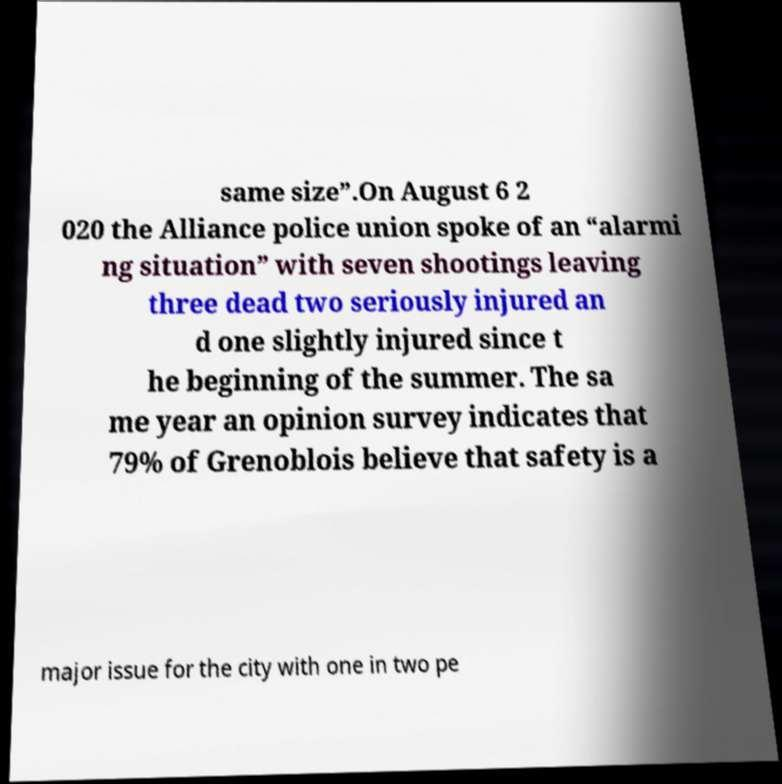Could you assist in decoding the text presented in this image and type it out clearly? same size”.On August 6 2 020 the Alliance police union spoke of an “alarmi ng situation” with seven shootings leaving three dead two seriously injured an d one slightly injured since t he beginning of the summer. The sa me year an opinion survey indicates that 79% of Grenoblois believe that safety is a major issue for the city with one in two pe 